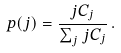<formula> <loc_0><loc_0><loc_500><loc_500>p ( j ) = \frac { j C _ { j } } { \sum _ { j } j C _ { j } } \, .</formula> 